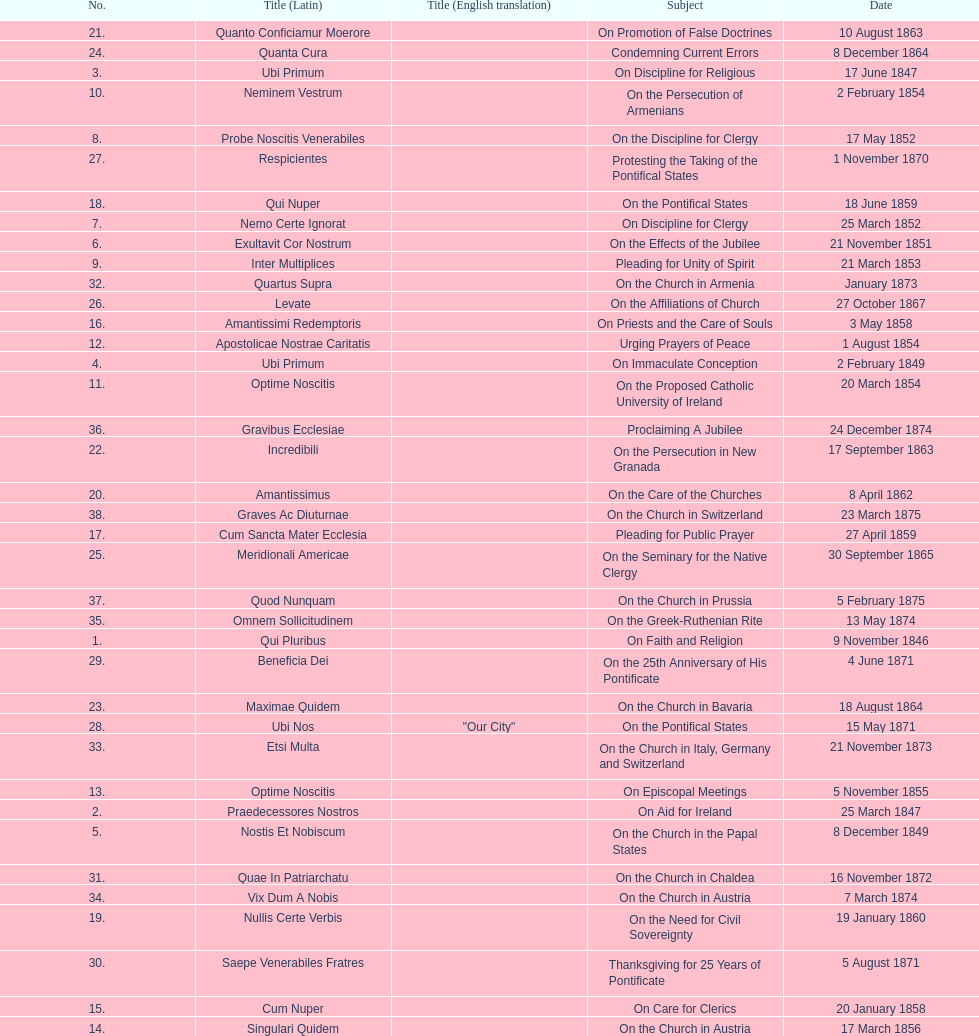What is the total number of title? 38. 